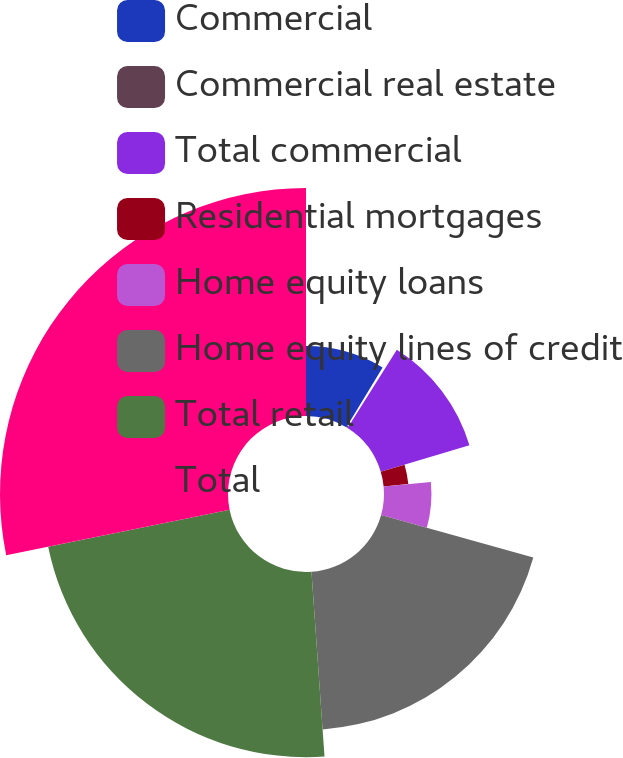<chart> <loc_0><loc_0><loc_500><loc_500><pie_chart><fcel>Commercial<fcel>Commercial real estate<fcel>Total commercial<fcel>Residential mortgages<fcel>Home equity loans<fcel>Home equity lines of credit<fcel>Total retail<fcel>Total<nl><fcel>8.66%<fcel>0.28%<fcel>11.45%<fcel>3.07%<fcel>5.87%<fcel>19.55%<fcel>22.91%<fcel>28.21%<nl></chart> 